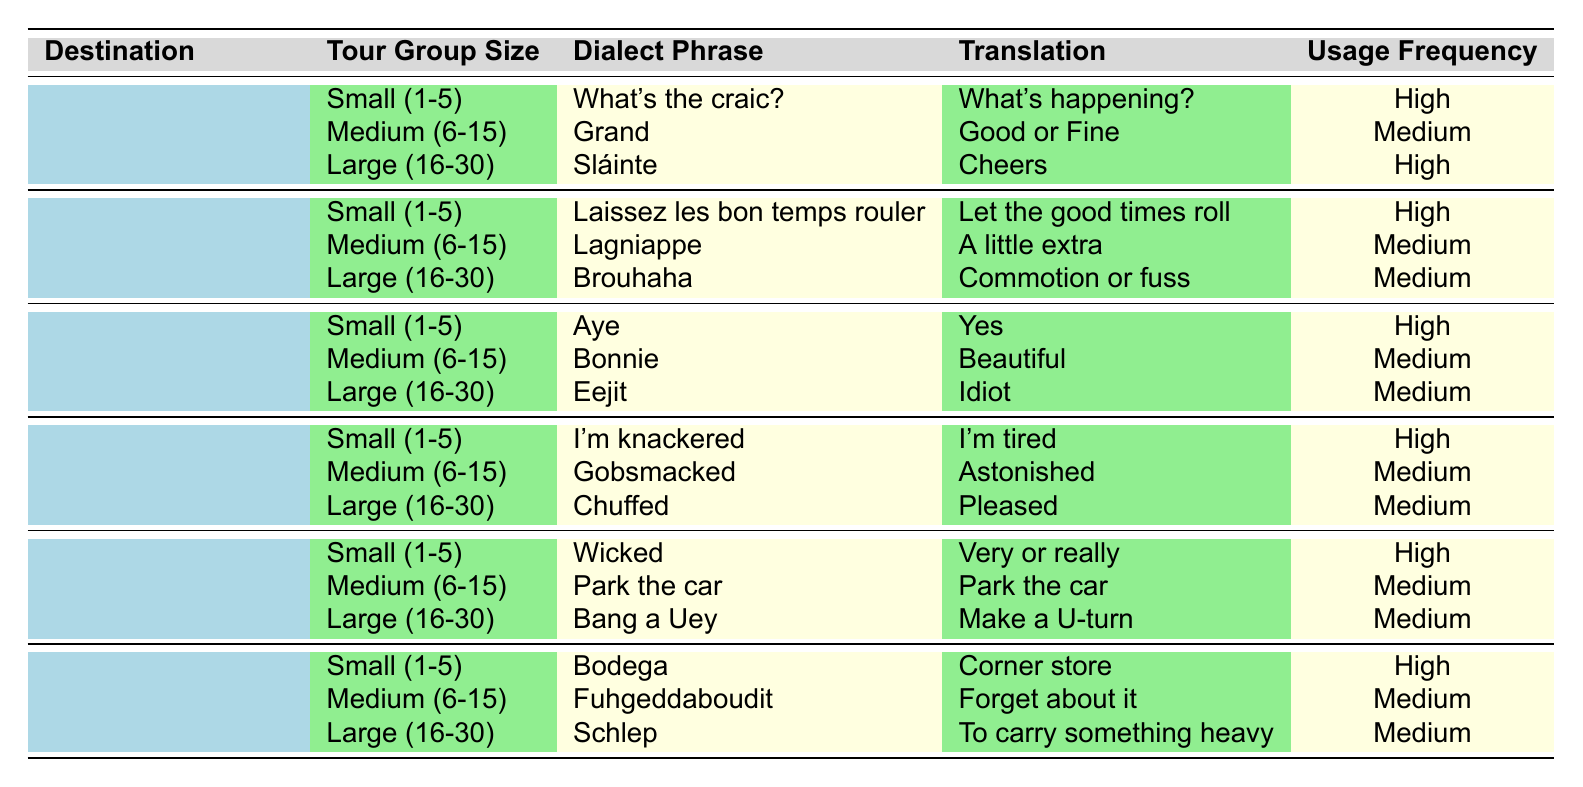What dialect phrase is used in Dublin, Ireland for a small tour group? According to the table, for a small tour group in Dublin, Ireland, the dialect phrase is "What's the craic?"
Answer: What's the craic? Which destination has the dialect phrase "Laissez les bon temps rouler"? The table indicates that "Laissez les bon temps rouler" is used in New Orleans, USA for small tour groups.
Answer: New Orleans, USA What is the translation of "Sláinte" from Dublin, Ireland? In the table, "Sláinte" is translated as "Cheers" in Dublin, Ireland.
Answer: Cheers How many medium-sized tour groups in Edinburgh, Scotland use a medium frequency dialect phrase? The table shows that "Bonnie" is the medium frequency phrase for medium-sized tour groups in Edinburgh, Scotland.
Answer: 1 Is "Wicked" used in Boston, USA for small tour groups? Yes, according to the table, "Wicked" is a dialect phrase used for small tour groups in Boston, USA.
Answer: Yes What is the usage frequency of the phrase "Gobsmacked" in London, England? The table lists "Gobsmacked" with a usage frequency of "Medium" for medium-sized tour groups in London, England.
Answer: Medium Which destination has the highest frequency usage of dialect phrases for large tour groups? Both Dublin, Ireland and New Orleans, USA have high frequency phrases for large groups, with "Sláinte" and "Brouhaha" respectively, but only Dublin has a high frequency for large groups.
Answer: Dublin, Ireland In terms of usage frequency, how does "Fuhgeddaboudit" compare to other dialect phrases used in New York City, USA? The usage frequency for "Fuhgeddaboudit" is "Medium," which makes it the second frequency tier among the three phrases in New York City.
Answer: Medium What is the average usage frequency level for phrases in small tour groups across all destinations? Looking at the table, the phrases for small groups mostly have a frequency of "High," indicating an average level of "High" since all are high.
Answer: High If a tour group in Edinburgh, Scotland is large, which dialect phrase would they use? The table shows that for large tour groups in Edinburgh, Scotland, the phrase used is "Eejit."
Answer: Eejit 